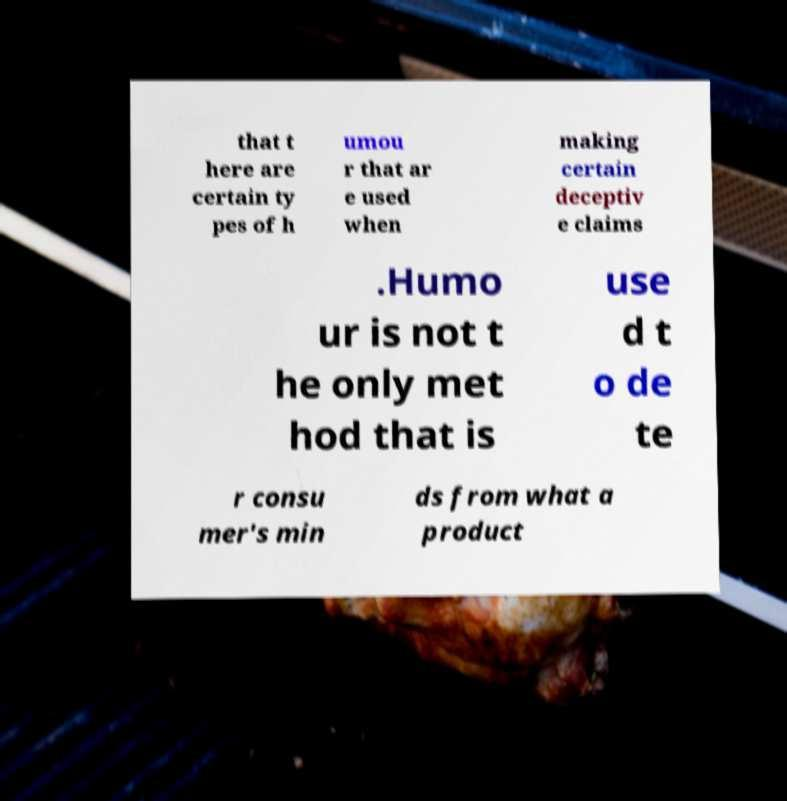Please identify and transcribe the text found in this image. that t here are certain ty pes of h umou r that ar e used when making certain deceptiv e claims .Humo ur is not t he only met hod that is use d t o de te r consu mer's min ds from what a product 